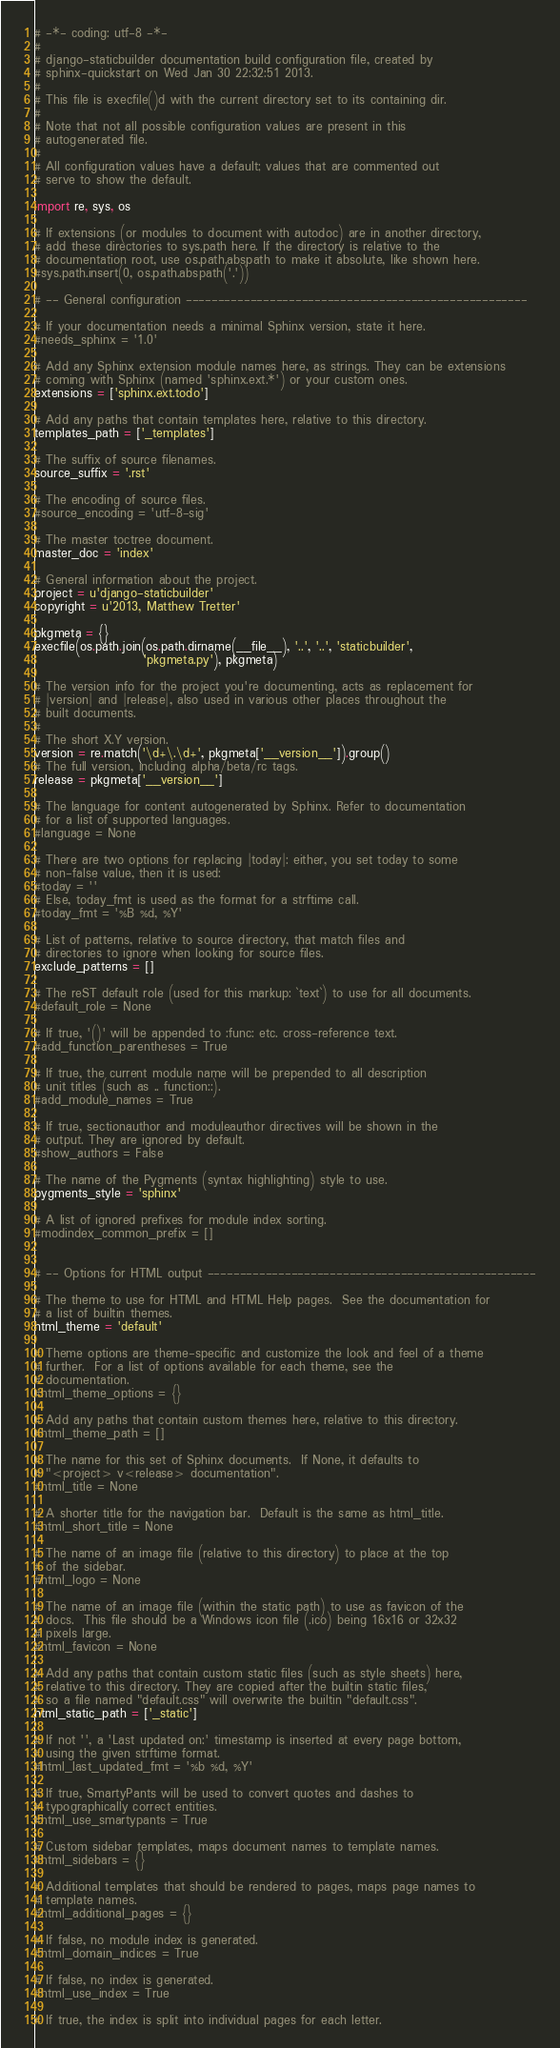<code> <loc_0><loc_0><loc_500><loc_500><_Python_># -*- coding: utf-8 -*-
#
# django-staticbuilder documentation build configuration file, created by
# sphinx-quickstart on Wed Jan 30 22:32:51 2013.
#
# This file is execfile()d with the current directory set to its containing dir.
#
# Note that not all possible configuration values are present in this
# autogenerated file.
#
# All configuration values have a default; values that are commented out
# serve to show the default.

import re, sys, os

# If extensions (or modules to document with autodoc) are in another directory,
# add these directories to sys.path here. If the directory is relative to the
# documentation root, use os.path.abspath to make it absolute, like shown here.
#sys.path.insert(0, os.path.abspath('.'))

# -- General configuration -----------------------------------------------------

# If your documentation needs a minimal Sphinx version, state it here.
#needs_sphinx = '1.0'

# Add any Sphinx extension module names here, as strings. They can be extensions
# coming with Sphinx (named 'sphinx.ext.*') or your custom ones.
extensions = ['sphinx.ext.todo']

# Add any paths that contain templates here, relative to this directory.
templates_path = ['_templates']

# The suffix of source filenames.
source_suffix = '.rst'

# The encoding of source files.
#source_encoding = 'utf-8-sig'

# The master toctree document.
master_doc = 'index'

# General information about the project.
project = u'django-staticbuilder'
copyright = u'2013, Matthew Tretter'

pkgmeta = {}
execfile(os.path.join(os.path.dirname(__file__), '..', '..', 'staticbuilder',
                      'pkgmeta.py'), pkgmeta)

# The version info for the project you're documenting, acts as replacement for
# |version| and |release|, also used in various other places throughout the
# built documents.
#
# The short X.Y version.
version = re.match('\d+\.\d+', pkgmeta['__version__']).group()
# The full version, including alpha/beta/rc tags.
release = pkgmeta['__version__']

# The language for content autogenerated by Sphinx. Refer to documentation
# for a list of supported languages.
#language = None

# There are two options for replacing |today|: either, you set today to some
# non-false value, then it is used:
#today = ''
# Else, today_fmt is used as the format for a strftime call.
#today_fmt = '%B %d, %Y'

# List of patterns, relative to source directory, that match files and
# directories to ignore when looking for source files.
exclude_patterns = []

# The reST default role (used for this markup: `text`) to use for all documents.
#default_role = None

# If true, '()' will be appended to :func: etc. cross-reference text.
#add_function_parentheses = True

# If true, the current module name will be prepended to all description
# unit titles (such as .. function::).
#add_module_names = True

# If true, sectionauthor and moduleauthor directives will be shown in the
# output. They are ignored by default.
#show_authors = False

# The name of the Pygments (syntax highlighting) style to use.
pygments_style = 'sphinx'

# A list of ignored prefixes for module index sorting.
#modindex_common_prefix = []


# -- Options for HTML output ---------------------------------------------------

# The theme to use for HTML and HTML Help pages.  See the documentation for
# a list of builtin themes.
html_theme = 'default'

# Theme options are theme-specific and customize the look and feel of a theme
# further.  For a list of options available for each theme, see the
# documentation.
#html_theme_options = {}

# Add any paths that contain custom themes here, relative to this directory.
#html_theme_path = []

# The name for this set of Sphinx documents.  If None, it defaults to
# "<project> v<release> documentation".
#html_title = None

# A shorter title for the navigation bar.  Default is the same as html_title.
#html_short_title = None

# The name of an image file (relative to this directory) to place at the top
# of the sidebar.
#html_logo = None

# The name of an image file (within the static path) to use as favicon of the
# docs.  This file should be a Windows icon file (.ico) being 16x16 or 32x32
# pixels large.
#html_favicon = None

# Add any paths that contain custom static files (such as style sheets) here,
# relative to this directory. They are copied after the builtin static files,
# so a file named "default.css" will overwrite the builtin "default.css".
html_static_path = ['_static']

# If not '', a 'Last updated on:' timestamp is inserted at every page bottom,
# using the given strftime format.
#html_last_updated_fmt = '%b %d, %Y'

# If true, SmartyPants will be used to convert quotes and dashes to
# typographically correct entities.
#html_use_smartypants = True

# Custom sidebar templates, maps document names to template names.
#html_sidebars = {}

# Additional templates that should be rendered to pages, maps page names to
# template names.
#html_additional_pages = {}

# If false, no module index is generated.
#html_domain_indices = True

# If false, no index is generated.
#html_use_index = True

# If true, the index is split into individual pages for each letter.</code> 